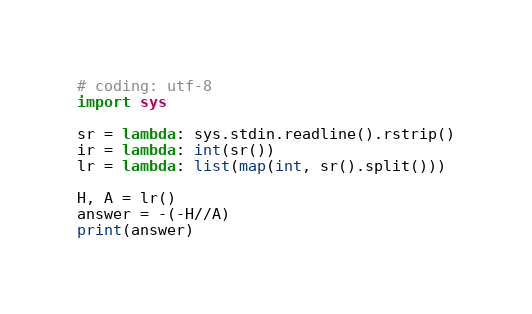<code> <loc_0><loc_0><loc_500><loc_500><_Python_># coding: utf-8
import sys

sr = lambda: sys.stdin.readline().rstrip()
ir = lambda: int(sr())
lr = lambda: list(map(int, sr().split()))

H, A = lr()
answer = -(-H//A)
print(answer)
</code> 